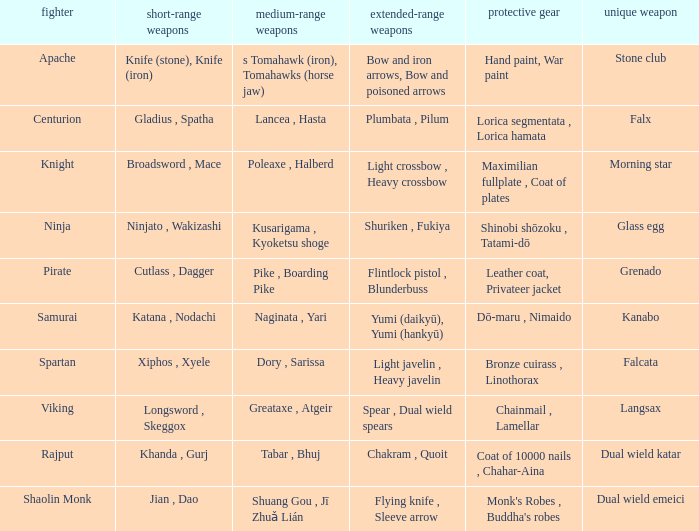If the special weapon is glass egg, what is the close ranged weapon? Ninjato , Wakizashi. 